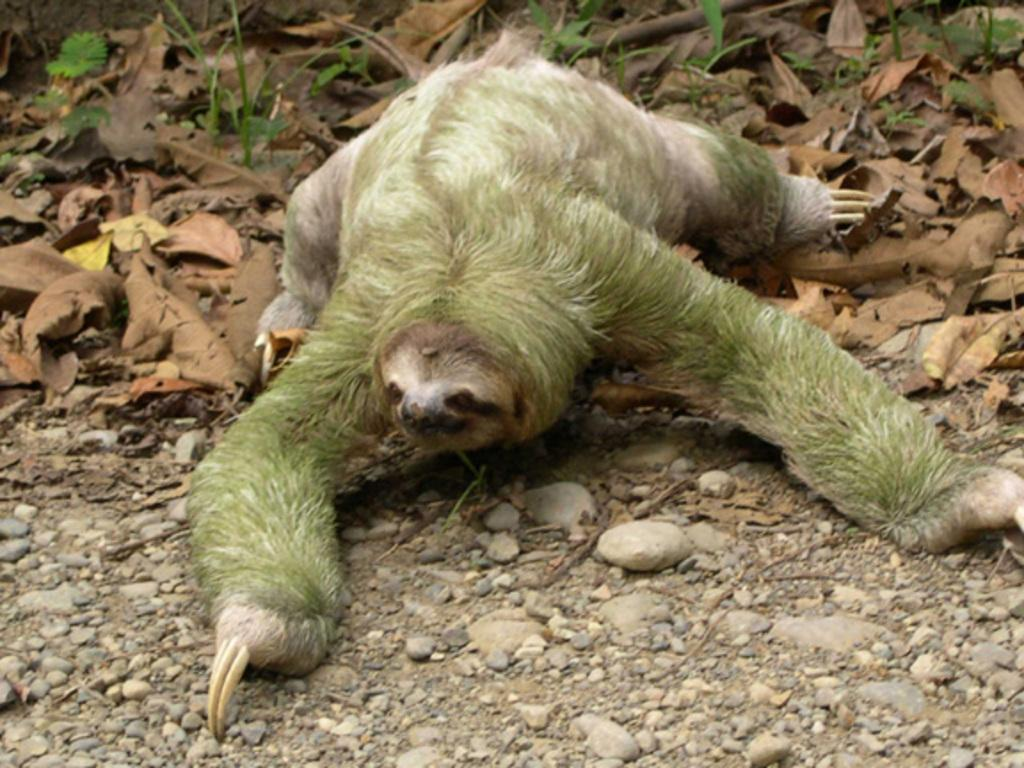What type of animal can be seen in the image? There is an animal in the image, but its specific type cannot be determined from the provided facts. What can be found among the leaves in the image? There are shredded leaves in the image. What is on the ground in the image? Stones are present on the ground in the image. What type of hat is the animal wearing in the image? There is no hat present in the image, and therefore the animal cannot be wearing one. 